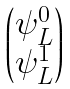<formula> <loc_0><loc_0><loc_500><loc_500>\begin{pmatrix} \psi _ { L } ^ { 0 } \\ \psi _ { L } ^ { 1 } \end{pmatrix}</formula> 